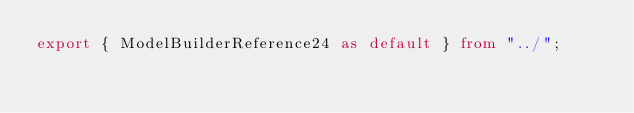Convert code to text. <code><loc_0><loc_0><loc_500><loc_500><_TypeScript_>export { ModelBuilderReference24 as default } from "../";
</code> 